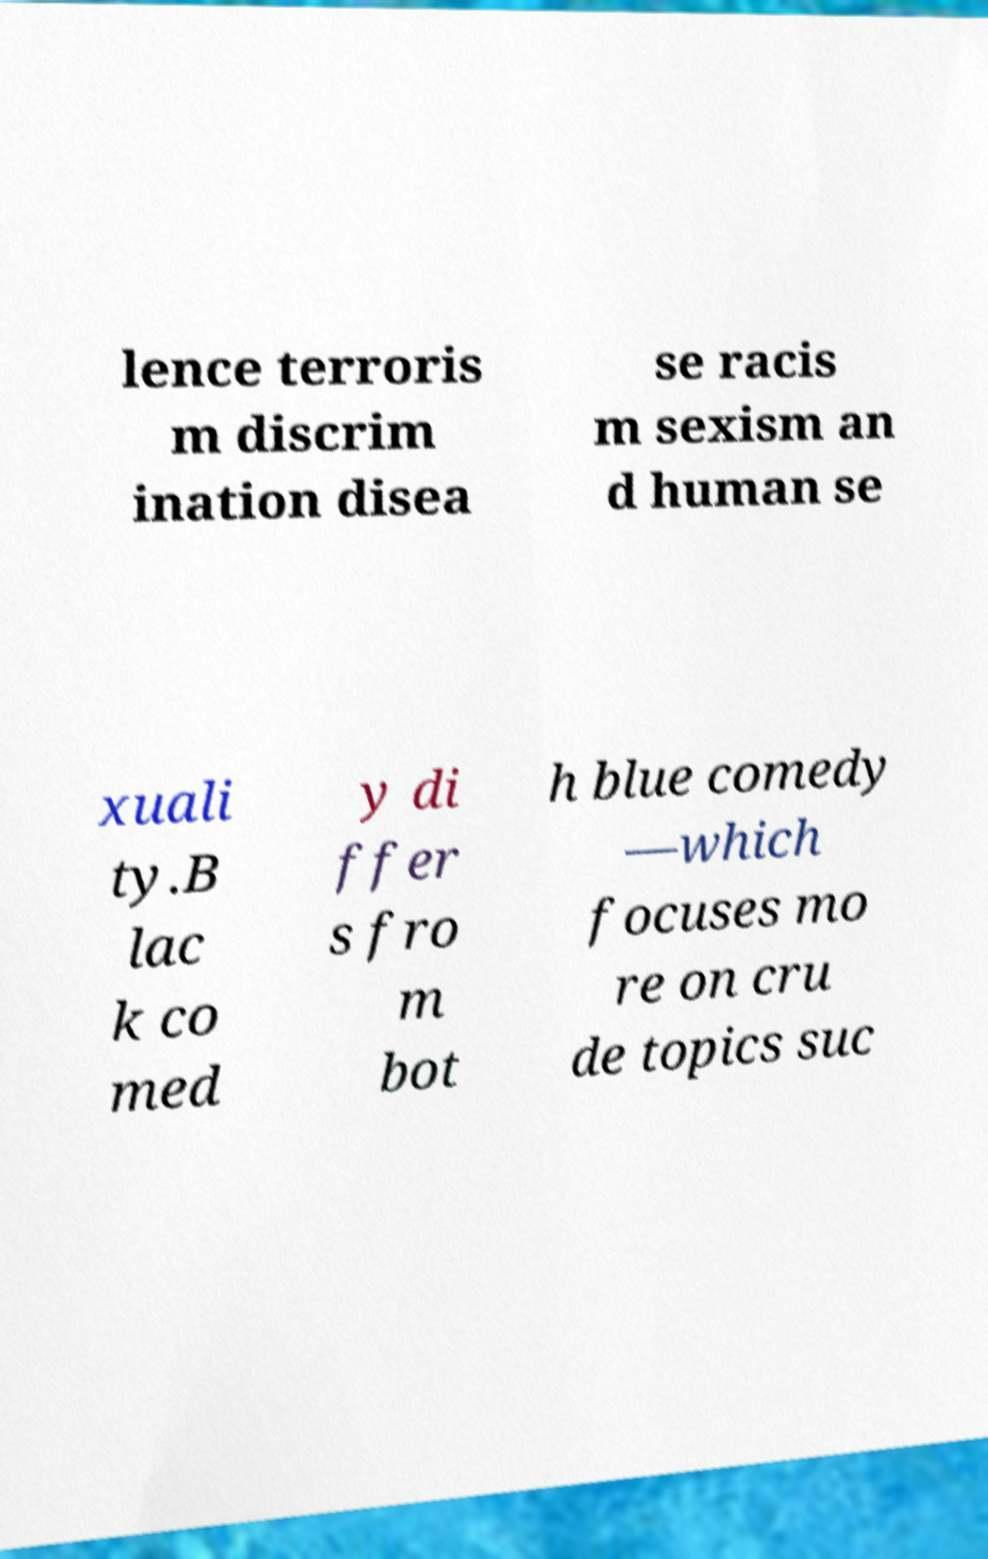Could you assist in decoding the text presented in this image and type it out clearly? lence terroris m discrim ination disea se racis m sexism an d human se xuali ty.B lac k co med y di ffer s fro m bot h blue comedy —which focuses mo re on cru de topics suc 